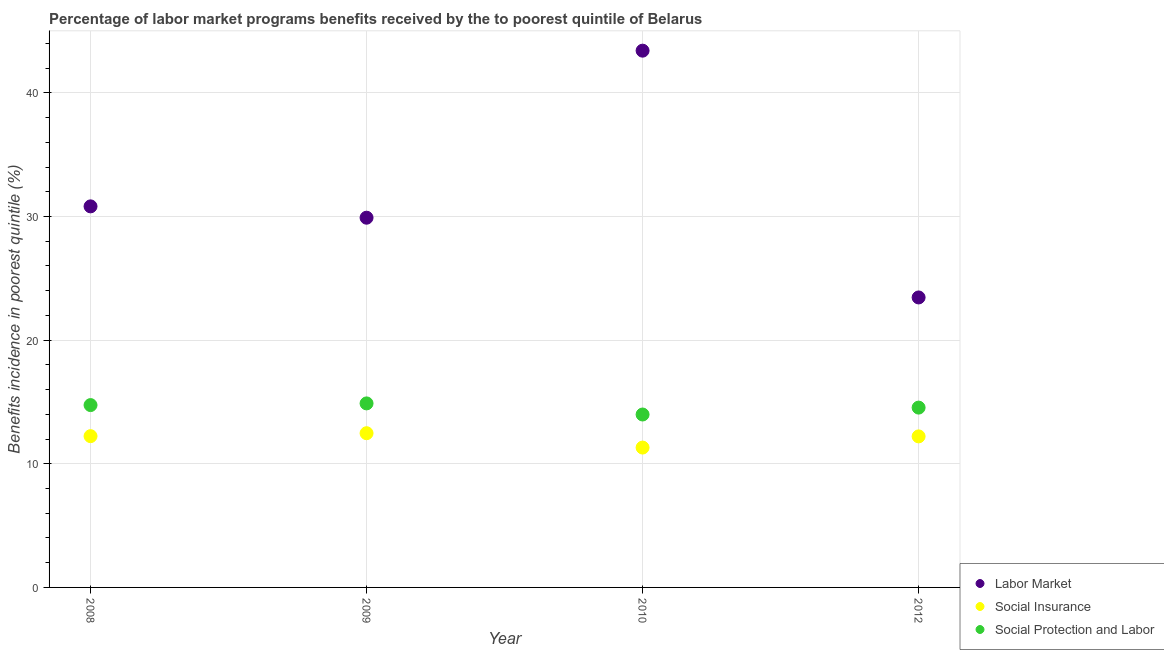How many different coloured dotlines are there?
Provide a short and direct response. 3. Is the number of dotlines equal to the number of legend labels?
Provide a succinct answer. Yes. What is the percentage of benefits received due to social insurance programs in 2009?
Offer a terse response. 12.47. Across all years, what is the maximum percentage of benefits received due to social protection programs?
Give a very brief answer. 14.89. Across all years, what is the minimum percentage of benefits received due to social insurance programs?
Keep it short and to the point. 11.31. In which year was the percentage of benefits received due to labor market programs maximum?
Keep it short and to the point. 2010. In which year was the percentage of benefits received due to labor market programs minimum?
Provide a succinct answer. 2012. What is the total percentage of benefits received due to labor market programs in the graph?
Give a very brief answer. 127.6. What is the difference between the percentage of benefits received due to social insurance programs in 2009 and that in 2012?
Provide a succinct answer. 0.26. What is the difference between the percentage of benefits received due to social protection programs in 2012 and the percentage of benefits received due to social insurance programs in 2008?
Ensure brevity in your answer.  2.31. What is the average percentage of benefits received due to labor market programs per year?
Your response must be concise. 31.9. In the year 2008, what is the difference between the percentage of benefits received due to social insurance programs and percentage of benefits received due to labor market programs?
Your answer should be compact. -18.59. In how many years, is the percentage of benefits received due to social insurance programs greater than 24 %?
Offer a terse response. 0. What is the ratio of the percentage of benefits received due to social protection programs in 2008 to that in 2010?
Your answer should be compact. 1.05. Is the percentage of benefits received due to labor market programs in 2008 less than that in 2009?
Your answer should be compact. No. What is the difference between the highest and the second highest percentage of benefits received due to labor market programs?
Offer a terse response. 12.59. What is the difference between the highest and the lowest percentage of benefits received due to social protection programs?
Make the answer very short. 0.9. Is the sum of the percentage of benefits received due to social protection programs in 2008 and 2009 greater than the maximum percentage of benefits received due to labor market programs across all years?
Make the answer very short. No. How many years are there in the graph?
Your answer should be compact. 4. What is the difference between two consecutive major ticks on the Y-axis?
Provide a succinct answer. 10. Does the graph contain any zero values?
Ensure brevity in your answer.  No. Does the graph contain grids?
Give a very brief answer. Yes. How many legend labels are there?
Your answer should be compact. 3. What is the title of the graph?
Keep it short and to the point. Percentage of labor market programs benefits received by the to poorest quintile of Belarus. What is the label or title of the Y-axis?
Provide a short and direct response. Benefits incidence in poorest quintile (%). What is the Benefits incidence in poorest quintile (%) of Labor Market in 2008?
Your response must be concise. 30.82. What is the Benefits incidence in poorest quintile (%) in Social Insurance in 2008?
Ensure brevity in your answer.  12.24. What is the Benefits incidence in poorest quintile (%) in Social Protection and Labor in 2008?
Provide a succinct answer. 14.75. What is the Benefits incidence in poorest quintile (%) of Labor Market in 2009?
Give a very brief answer. 29.9. What is the Benefits incidence in poorest quintile (%) in Social Insurance in 2009?
Offer a very short reply. 12.47. What is the Benefits incidence in poorest quintile (%) in Social Protection and Labor in 2009?
Your answer should be very brief. 14.89. What is the Benefits incidence in poorest quintile (%) in Labor Market in 2010?
Your answer should be very brief. 43.42. What is the Benefits incidence in poorest quintile (%) in Social Insurance in 2010?
Your answer should be very brief. 11.31. What is the Benefits incidence in poorest quintile (%) in Social Protection and Labor in 2010?
Provide a succinct answer. 13.99. What is the Benefits incidence in poorest quintile (%) of Labor Market in 2012?
Offer a terse response. 23.45. What is the Benefits incidence in poorest quintile (%) of Social Insurance in 2012?
Keep it short and to the point. 12.22. What is the Benefits incidence in poorest quintile (%) of Social Protection and Labor in 2012?
Give a very brief answer. 14.54. Across all years, what is the maximum Benefits incidence in poorest quintile (%) of Labor Market?
Your response must be concise. 43.42. Across all years, what is the maximum Benefits incidence in poorest quintile (%) of Social Insurance?
Your answer should be very brief. 12.47. Across all years, what is the maximum Benefits incidence in poorest quintile (%) of Social Protection and Labor?
Your response must be concise. 14.89. Across all years, what is the minimum Benefits incidence in poorest quintile (%) in Labor Market?
Make the answer very short. 23.45. Across all years, what is the minimum Benefits incidence in poorest quintile (%) in Social Insurance?
Make the answer very short. 11.31. Across all years, what is the minimum Benefits incidence in poorest quintile (%) in Social Protection and Labor?
Provide a short and direct response. 13.99. What is the total Benefits incidence in poorest quintile (%) in Labor Market in the graph?
Ensure brevity in your answer.  127.6. What is the total Benefits incidence in poorest quintile (%) of Social Insurance in the graph?
Ensure brevity in your answer.  48.24. What is the total Benefits incidence in poorest quintile (%) in Social Protection and Labor in the graph?
Offer a terse response. 58.16. What is the difference between the Benefits incidence in poorest quintile (%) in Labor Market in 2008 and that in 2009?
Provide a short and direct response. 0.92. What is the difference between the Benefits incidence in poorest quintile (%) in Social Insurance in 2008 and that in 2009?
Provide a succinct answer. -0.24. What is the difference between the Benefits incidence in poorest quintile (%) of Social Protection and Labor in 2008 and that in 2009?
Make the answer very short. -0.14. What is the difference between the Benefits incidence in poorest quintile (%) in Labor Market in 2008 and that in 2010?
Your response must be concise. -12.59. What is the difference between the Benefits incidence in poorest quintile (%) in Social Insurance in 2008 and that in 2010?
Your answer should be very brief. 0.92. What is the difference between the Benefits incidence in poorest quintile (%) in Social Protection and Labor in 2008 and that in 2010?
Your answer should be very brief. 0.76. What is the difference between the Benefits incidence in poorest quintile (%) of Labor Market in 2008 and that in 2012?
Offer a very short reply. 7.37. What is the difference between the Benefits incidence in poorest quintile (%) in Social Insurance in 2008 and that in 2012?
Your answer should be compact. 0.02. What is the difference between the Benefits incidence in poorest quintile (%) of Social Protection and Labor in 2008 and that in 2012?
Make the answer very short. 0.2. What is the difference between the Benefits incidence in poorest quintile (%) of Labor Market in 2009 and that in 2010?
Offer a very short reply. -13.51. What is the difference between the Benefits incidence in poorest quintile (%) in Social Insurance in 2009 and that in 2010?
Offer a terse response. 1.16. What is the difference between the Benefits incidence in poorest quintile (%) in Social Protection and Labor in 2009 and that in 2010?
Your answer should be compact. 0.9. What is the difference between the Benefits incidence in poorest quintile (%) of Labor Market in 2009 and that in 2012?
Offer a terse response. 6.45. What is the difference between the Benefits incidence in poorest quintile (%) in Social Insurance in 2009 and that in 2012?
Offer a very short reply. 0.26. What is the difference between the Benefits incidence in poorest quintile (%) of Social Protection and Labor in 2009 and that in 2012?
Make the answer very short. 0.34. What is the difference between the Benefits incidence in poorest quintile (%) of Labor Market in 2010 and that in 2012?
Provide a short and direct response. 19.96. What is the difference between the Benefits incidence in poorest quintile (%) in Social Insurance in 2010 and that in 2012?
Your answer should be compact. -0.9. What is the difference between the Benefits incidence in poorest quintile (%) of Social Protection and Labor in 2010 and that in 2012?
Your answer should be very brief. -0.56. What is the difference between the Benefits incidence in poorest quintile (%) of Labor Market in 2008 and the Benefits incidence in poorest quintile (%) of Social Insurance in 2009?
Ensure brevity in your answer.  18.35. What is the difference between the Benefits incidence in poorest quintile (%) in Labor Market in 2008 and the Benefits incidence in poorest quintile (%) in Social Protection and Labor in 2009?
Offer a terse response. 15.94. What is the difference between the Benefits incidence in poorest quintile (%) in Social Insurance in 2008 and the Benefits incidence in poorest quintile (%) in Social Protection and Labor in 2009?
Ensure brevity in your answer.  -2.65. What is the difference between the Benefits incidence in poorest quintile (%) in Labor Market in 2008 and the Benefits incidence in poorest quintile (%) in Social Insurance in 2010?
Provide a succinct answer. 19.51. What is the difference between the Benefits incidence in poorest quintile (%) in Labor Market in 2008 and the Benefits incidence in poorest quintile (%) in Social Protection and Labor in 2010?
Provide a short and direct response. 16.84. What is the difference between the Benefits incidence in poorest quintile (%) of Social Insurance in 2008 and the Benefits incidence in poorest quintile (%) of Social Protection and Labor in 2010?
Your answer should be very brief. -1.75. What is the difference between the Benefits incidence in poorest quintile (%) in Labor Market in 2008 and the Benefits incidence in poorest quintile (%) in Social Insurance in 2012?
Your answer should be compact. 18.61. What is the difference between the Benefits incidence in poorest quintile (%) of Labor Market in 2008 and the Benefits incidence in poorest quintile (%) of Social Protection and Labor in 2012?
Keep it short and to the point. 16.28. What is the difference between the Benefits incidence in poorest quintile (%) in Social Insurance in 2008 and the Benefits incidence in poorest quintile (%) in Social Protection and Labor in 2012?
Make the answer very short. -2.31. What is the difference between the Benefits incidence in poorest quintile (%) of Labor Market in 2009 and the Benefits incidence in poorest quintile (%) of Social Insurance in 2010?
Provide a succinct answer. 18.59. What is the difference between the Benefits incidence in poorest quintile (%) in Labor Market in 2009 and the Benefits incidence in poorest quintile (%) in Social Protection and Labor in 2010?
Offer a terse response. 15.92. What is the difference between the Benefits incidence in poorest quintile (%) in Social Insurance in 2009 and the Benefits incidence in poorest quintile (%) in Social Protection and Labor in 2010?
Provide a succinct answer. -1.51. What is the difference between the Benefits incidence in poorest quintile (%) of Labor Market in 2009 and the Benefits incidence in poorest quintile (%) of Social Insurance in 2012?
Your response must be concise. 17.69. What is the difference between the Benefits incidence in poorest quintile (%) of Labor Market in 2009 and the Benefits incidence in poorest quintile (%) of Social Protection and Labor in 2012?
Provide a short and direct response. 15.36. What is the difference between the Benefits incidence in poorest quintile (%) of Social Insurance in 2009 and the Benefits incidence in poorest quintile (%) of Social Protection and Labor in 2012?
Offer a terse response. -2.07. What is the difference between the Benefits incidence in poorest quintile (%) in Labor Market in 2010 and the Benefits incidence in poorest quintile (%) in Social Insurance in 2012?
Ensure brevity in your answer.  31.2. What is the difference between the Benefits incidence in poorest quintile (%) in Labor Market in 2010 and the Benefits incidence in poorest quintile (%) in Social Protection and Labor in 2012?
Offer a terse response. 28.87. What is the difference between the Benefits incidence in poorest quintile (%) in Social Insurance in 2010 and the Benefits incidence in poorest quintile (%) in Social Protection and Labor in 2012?
Provide a short and direct response. -3.23. What is the average Benefits incidence in poorest quintile (%) in Labor Market per year?
Ensure brevity in your answer.  31.9. What is the average Benefits incidence in poorest quintile (%) of Social Insurance per year?
Provide a short and direct response. 12.06. What is the average Benefits incidence in poorest quintile (%) in Social Protection and Labor per year?
Make the answer very short. 14.54. In the year 2008, what is the difference between the Benefits incidence in poorest quintile (%) of Labor Market and Benefits incidence in poorest quintile (%) of Social Insurance?
Your response must be concise. 18.59. In the year 2008, what is the difference between the Benefits incidence in poorest quintile (%) in Labor Market and Benefits incidence in poorest quintile (%) in Social Protection and Labor?
Your response must be concise. 16.07. In the year 2008, what is the difference between the Benefits incidence in poorest quintile (%) in Social Insurance and Benefits incidence in poorest quintile (%) in Social Protection and Labor?
Provide a succinct answer. -2.51. In the year 2009, what is the difference between the Benefits incidence in poorest quintile (%) in Labor Market and Benefits incidence in poorest quintile (%) in Social Insurance?
Make the answer very short. 17.43. In the year 2009, what is the difference between the Benefits incidence in poorest quintile (%) in Labor Market and Benefits incidence in poorest quintile (%) in Social Protection and Labor?
Make the answer very short. 15.02. In the year 2009, what is the difference between the Benefits incidence in poorest quintile (%) in Social Insurance and Benefits incidence in poorest quintile (%) in Social Protection and Labor?
Keep it short and to the point. -2.41. In the year 2010, what is the difference between the Benefits incidence in poorest quintile (%) of Labor Market and Benefits incidence in poorest quintile (%) of Social Insurance?
Offer a very short reply. 32.1. In the year 2010, what is the difference between the Benefits incidence in poorest quintile (%) of Labor Market and Benefits incidence in poorest quintile (%) of Social Protection and Labor?
Your answer should be compact. 29.43. In the year 2010, what is the difference between the Benefits incidence in poorest quintile (%) of Social Insurance and Benefits incidence in poorest quintile (%) of Social Protection and Labor?
Make the answer very short. -2.67. In the year 2012, what is the difference between the Benefits incidence in poorest quintile (%) of Labor Market and Benefits incidence in poorest quintile (%) of Social Insurance?
Your answer should be very brief. 11.24. In the year 2012, what is the difference between the Benefits incidence in poorest quintile (%) of Labor Market and Benefits incidence in poorest quintile (%) of Social Protection and Labor?
Your response must be concise. 8.91. In the year 2012, what is the difference between the Benefits incidence in poorest quintile (%) of Social Insurance and Benefits incidence in poorest quintile (%) of Social Protection and Labor?
Provide a succinct answer. -2.33. What is the ratio of the Benefits incidence in poorest quintile (%) of Labor Market in 2008 to that in 2009?
Your answer should be very brief. 1.03. What is the ratio of the Benefits incidence in poorest quintile (%) of Social Insurance in 2008 to that in 2009?
Offer a very short reply. 0.98. What is the ratio of the Benefits incidence in poorest quintile (%) in Labor Market in 2008 to that in 2010?
Offer a very short reply. 0.71. What is the ratio of the Benefits incidence in poorest quintile (%) in Social Insurance in 2008 to that in 2010?
Your answer should be very brief. 1.08. What is the ratio of the Benefits incidence in poorest quintile (%) in Social Protection and Labor in 2008 to that in 2010?
Your answer should be very brief. 1.05. What is the ratio of the Benefits incidence in poorest quintile (%) in Labor Market in 2008 to that in 2012?
Offer a terse response. 1.31. What is the ratio of the Benefits incidence in poorest quintile (%) in Social Protection and Labor in 2008 to that in 2012?
Provide a succinct answer. 1.01. What is the ratio of the Benefits incidence in poorest quintile (%) of Labor Market in 2009 to that in 2010?
Your response must be concise. 0.69. What is the ratio of the Benefits incidence in poorest quintile (%) in Social Insurance in 2009 to that in 2010?
Provide a short and direct response. 1.1. What is the ratio of the Benefits incidence in poorest quintile (%) of Social Protection and Labor in 2009 to that in 2010?
Your answer should be very brief. 1.06. What is the ratio of the Benefits incidence in poorest quintile (%) in Labor Market in 2009 to that in 2012?
Provide a short and direct response. 1.27. What is the ratio of the Benefits incidence in poorest quintile (%) of Social Protection and Labor in 2009 to that in 2012?
Your answer should be compact. 1.02. What is the ratio of the Benefits incidence in poorest quintile (%) of Labor Market in 2010 to that in 2012?
Your answer should be very brief. 1.85. What is the ratio of the Benefits incidence in poorest quintile (%) of Social Insurance in 2010 to that in 2012?
Ensure brevity in your answer.  0.93. What is the ratio of the Benefits incidence in poorest quintile (%) of Social Protection and Labor in 2010 to that in 2012?
Offer a terse response. 0.96. What is the difference between the highest and the second highest Benefits incidence in poorest quintile (%) of Labor Market?
Your answer should be very brief. 12.59. What is the difference between the highest and the second highest Benefits incidence in poorest quintile (%) of Social Insurance?
Provide a succinct answer. 0.24. What is the difference between the highest and the second highest Benefits incidence in poorest quintile (%) in Social Protection and Labor?
Ensure brevity in your answer.  0.14. What is the difference between the highest and the lowest Benefits incidence in poorest quintile (%) in Labor Market?
Make the answer very short. 19.96. What is the difference between the highest and the lowest Benefits incidence in poorest quintile (%) in Social Insurance?
Provide a succinct answer. 1.16. What is the difference between the highest and the lowest Benefits incidence in poorest quintile (%) in Social Protection and Labor?
Make the answer very short. 0.9. 